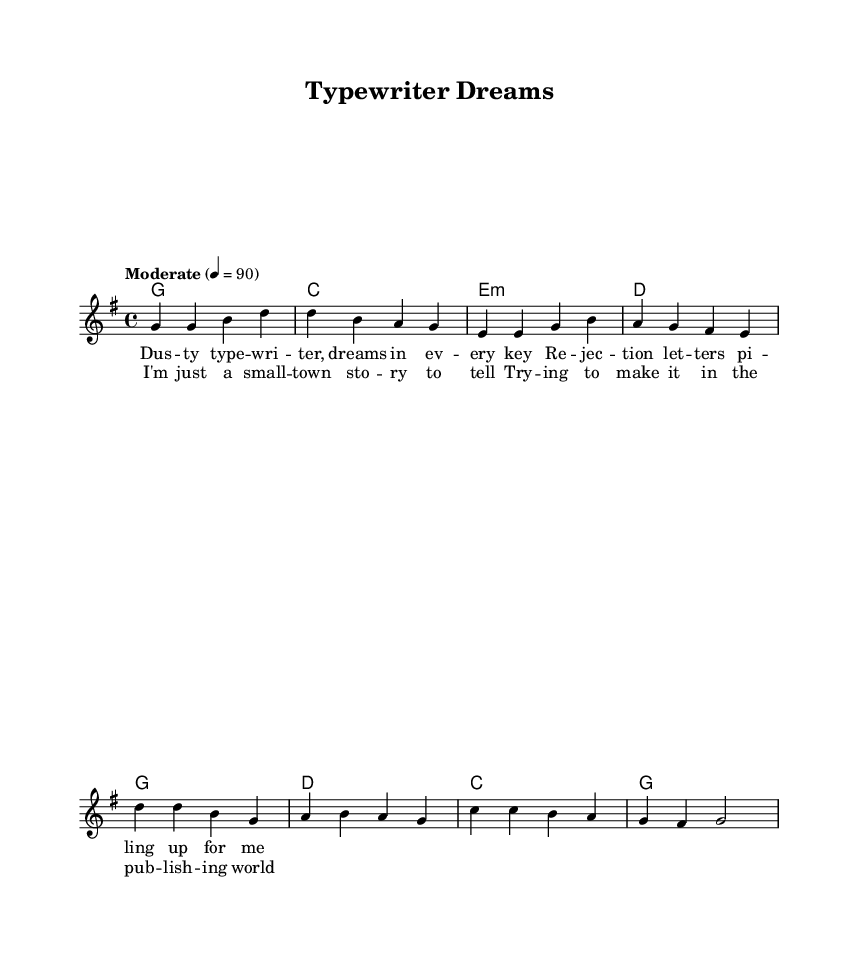What is the key signature of this music? The key signature is G major, which has one sharp (F#). This can be inferred from the global settings indicated at the top of the LilyPond code.
Answer: G major What is the time signature of this music? The time signature is 4/4, as specified in the global settings. This means there are four beats in each measure, and a quarter note receives one beat.
Answer: 4/4 What is the tempo marking for this piece? The tempo marking is "Moderate" with a metronome marking of 90 beats per minute. This is stated clearly in the global settings.
Answer: Moderate How many measures are there in the verse before the chorus starts? There are four measures in the verse before transitioning to the chorus. By counting the measures outlined in the melody section, we determine they conclude right before the chorus.
Answer: Four What is the first lyric line of the verse? The first lyric line of the verse is "Dusty typewriter, dreams in every key." This can be found in the lyric mode section labeled as verseOne.
Answer: Dusty typewriter, dreams in every key How many chords are used in the verse? Four unique chords are used in the verse: G, C, E minor, and D. This is illustrated in the harmonies section where the respective chords are detailed.
Answer: Four What theme do the lyrics of this song reflect? The lyrics reflect the theme of aspiring authors trying to achieve success despite challenges, indicated by references to rejection letters and dreams. This theme aligns with classic country storytelling.
Answer: Aspiration 